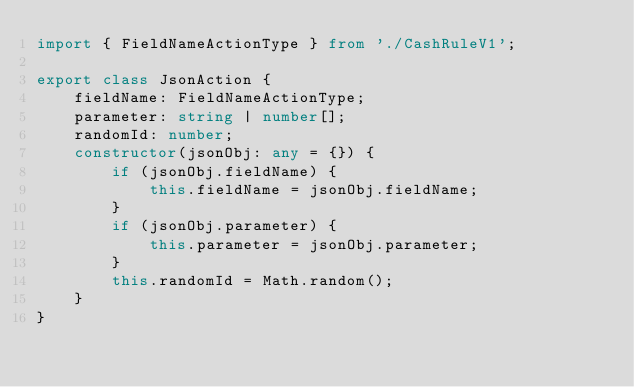Convert code to text. <code><loc_0><loc_0><loc_500><loc_500><_TypeScript_>import { FieldNameActionType } from './CashRuleV1';

export class JsonAction {
    fieldName: FieldNameActionType;
    parameter: string | number[];
    randomId: number;
    constructor(jsonObj: any = {}) {
        if (jsonObj.fieldName) {
            this.fieldName = jsonObj.fieldName;
        }
        if (jsonObj.parameter) {
            this.parameter = jsonObj.parameter;
        }
        this.randomId = Math.random();
    }
}
</code> 